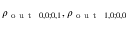<formula> <loc_0><loc_0><loc_500><loc_500>\rho _ { o u t 0 , 0 ; 0 , 1 } , \rho _ { o u t 1 , 0 ; 0 , 0 }</formula> 